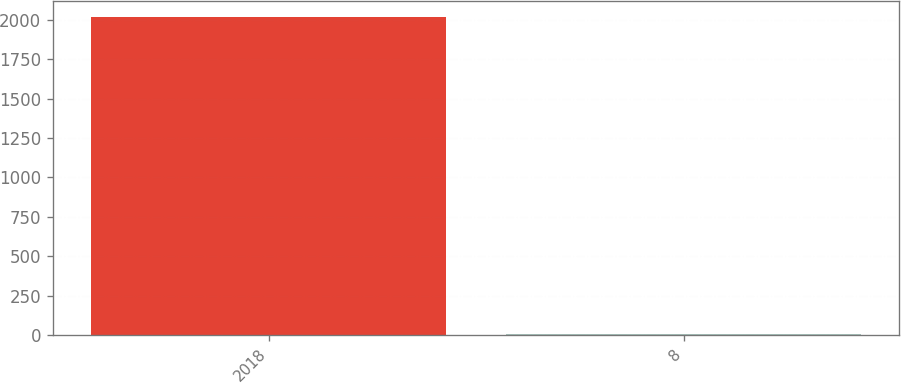Convert chart. <chart><loc_0><loc_0><loc_500><loc_500><bar_chart><fcel>2018<fcel>8<nl><fcel>2016<fcel>5<nl></chart> 